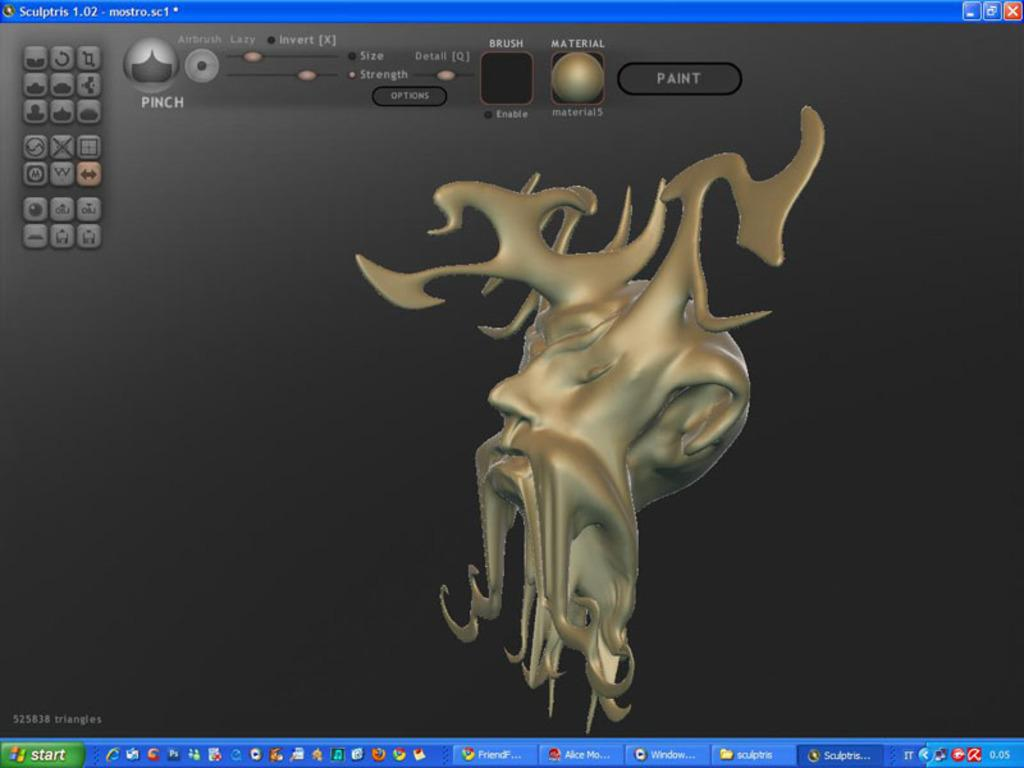<image>
Summarize the visual content of the image. A computer screen that says things like airbrush and pinch. 